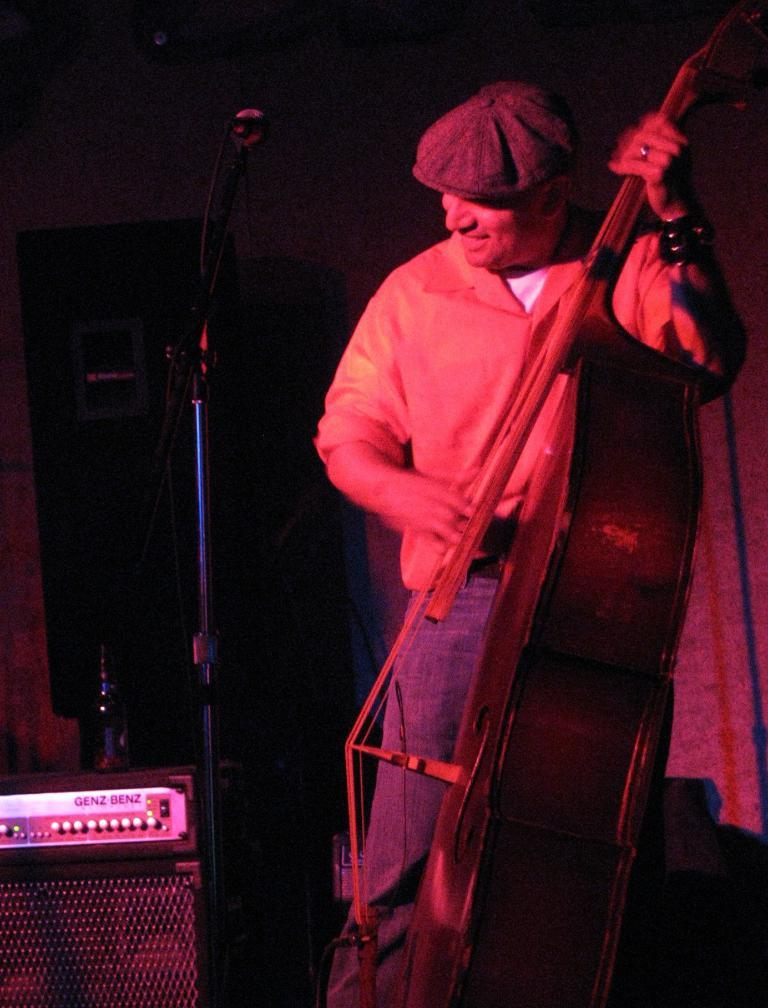What is the main subject of the image? There is a man in the image. What is the man doing in the image? The man is standing in the image. What is the man holding in the image? The man is holding a musical instrument in the image. What type of headwear is the man wearing in the image? The man is wearing a cap in the image. What channel is the man tuning on the stove in the image? There is no stove or channel mentioned in the image; it only features a man standing and holding a musical instrument. 